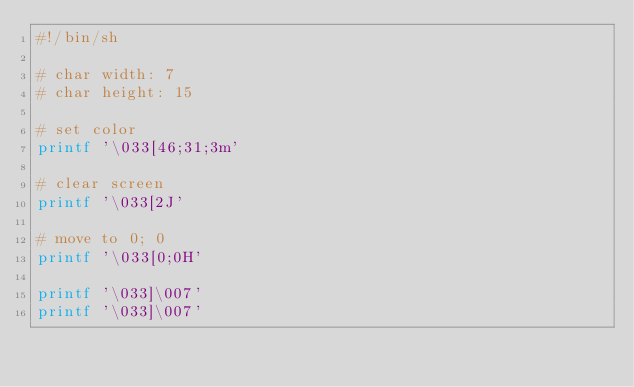<code> <loc_0><loc_0><loc_500><loc_500><_Bash_>#!/bin/sh

# char width: 7
# char height: 15

# set color
printf '\033[46;31;3m'

# clear screen
printf '\033[2J'

# move to 0; 0
printf '\033[0;0H'

printf '\033]\007'
printf '\033]\007'
</code> 